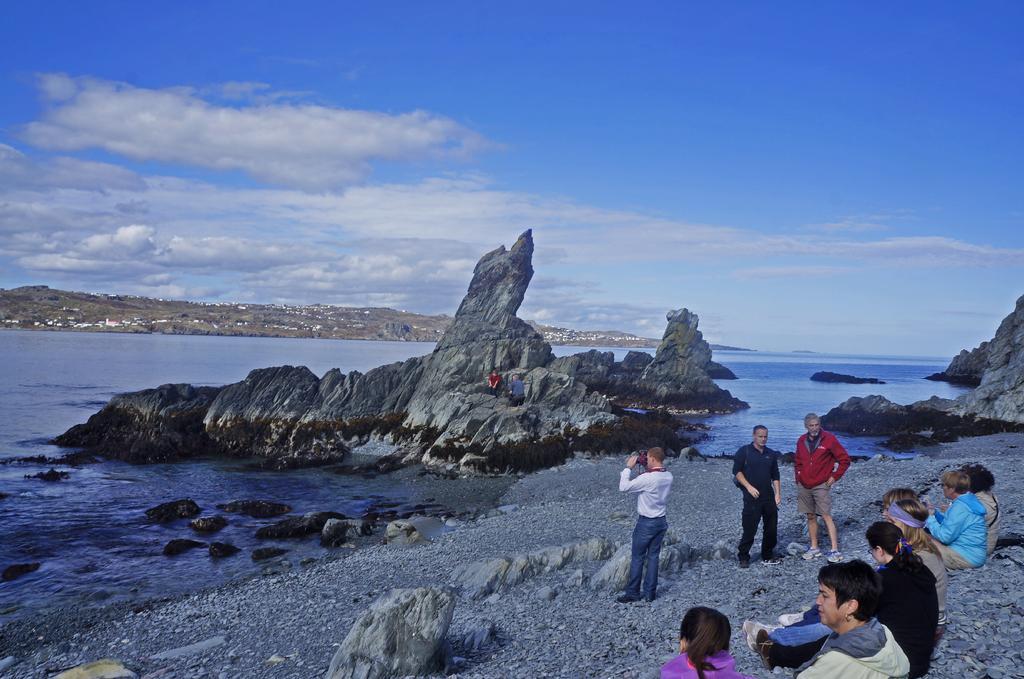Describe this image in one or two sentences. In the foreground I can see a group of people on the ground. In the background I can see mountains, water, trees, houses and the sky. This image is taken may be near the ocean. 